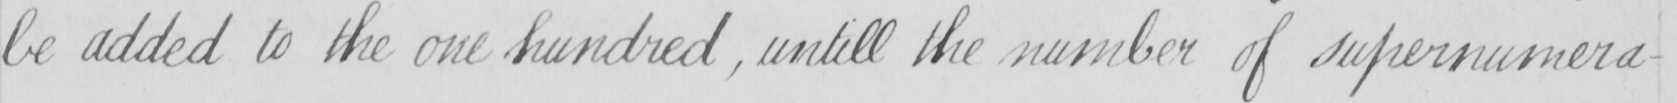Transcribe the text shown in this historical manuscript line. be added to the one hundred , untill the number of supernumera- 